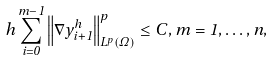Convert formula to latex. <formula><loc_0><loc_0><loc_500><loc_500>h \sum _ { i = 0 } ^ { m - 1 } \left \| \nabla y _ { i + 1 } ^ { h } \right \| _ { L ^ { p } ( \Omega ) } ^ { p } \leq C , m = 1 , \dots , n ,</formula> 